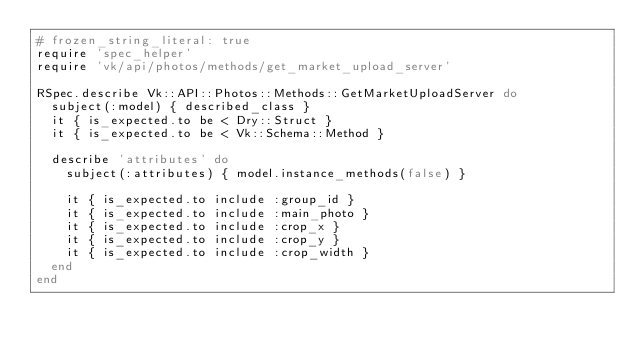<code> <loc_0><loc_0><loc_500><loc_500><_Ruby_># frozen_string_literal: true
require 'spec_helper'
require 'vk/api/photos/methods/get_market_upload_server'

RSpec.describe Vk::API::Photos::Methods::GetMarketUploadServer do
  subject(:model) { described_class }
  it { is_expected.to be < Dry::Struct }
  it { is_expected.to be < Vk::Schema::Method }

  describe 'attributes' do
    subject(:attributes) { model.instance_methods(false) }

    it { is_expected.to include :group_id }
    it { is_expected.to include :main_photo }
    it { is_expected.to include :crop_x }
    it { is_expected.to include :crop_y }
    it { is_expected.to include :crop_width }
  end
end
</code> 